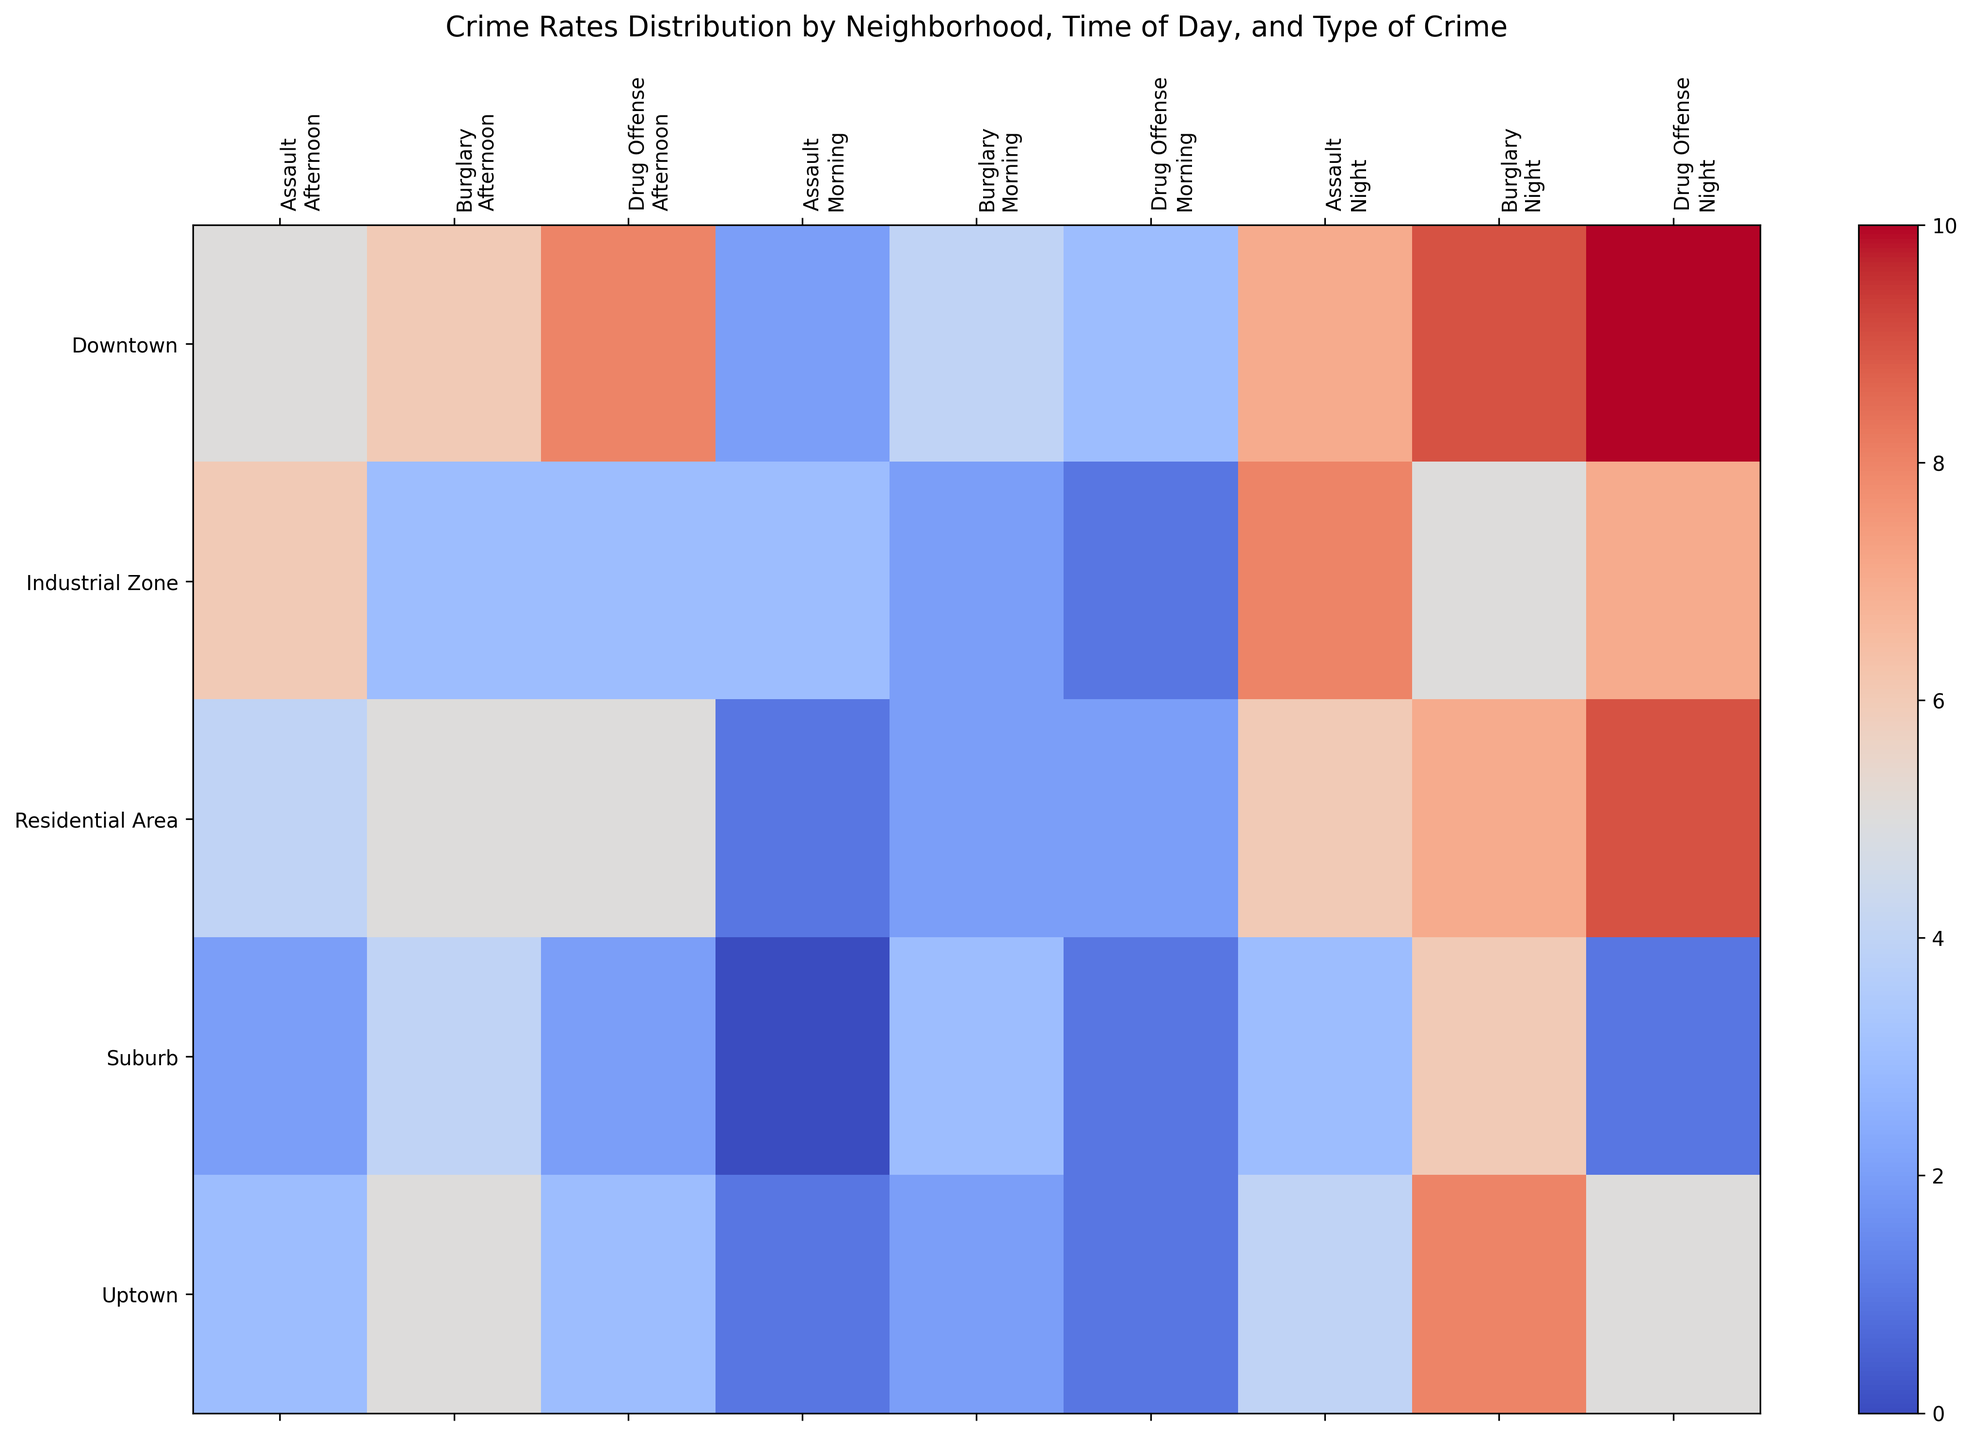Which neighborhood has the highest crime rate for Drug Offenses at night? By looking at the color intensity corresponding to different neighborhoods for Drug Offenses at night, we can see that Downtown has the darkest shade, indicating the highest crime rate.
Answer: Downtown Out of all neighborhoods, which has the smallest variance in Assault rates throughout the day? To find the neighborhood with the smallest variance in Assault rates throughout the day, we look at the variation in color intensity within the Assault column for each neighborhood. The Suburb has the least variation as the shades are more uniform.
Answer: Suburb Is the average Burglary rate in Downtown higher, lower, or equal compared to Uptown? To determine this, calculate the average Burglary rate for both neighborhoods. For Downtown: (4+6+9)/3 = 19/3 = 6.33. For Uptown: (2+5+8)/3 = 15/3 = 5. Therefore, the average Burglary rate in Downtown is higher.
Answer: Higher Which time of the day has the highest average Assault rate across all neighborhoods? Calculate the average Assault rate for Morning, Afternoon, and Night by summing up the values per time and dividing by the number of neighborhoods. The sums are 7 (Morning), 20 (Afternoon), and 28 (Night). Thus, Night has the highest average Assault rate: 28/5 = 5.6.
Answer: Night In which neighborhood and for which type of crime do we see the most intense color gradient from Morning to Night? Observing the heatmap, we identify that Downtown for Drug Offenses shows the most significant color change from a lighter shade in the morning to a very dark shade at night, indicating a steep increase in crime rate.
Answer: Downtown, Drug Offenses Compare the Assault rates between Residential Area and Industrial Zone at night. Which one is higher? By referring to the night's column for Assault, we see that the Industrial Zone has an Assault rate of 8 compared to 6 in the Residential Area, making the Industrial Zone higher.
Answer: Industrial Zone Summarize the change in Burglary rates throughout the day in the Industrial Zone. In the heatmap, note the increasing color intensity for Burglary in the Industrial Zone from Morning (2), Afternoon (3), to Night (5). It indicates a linear increase as the day progresses.
Answer: Increased Which neighborhood has the least severe Drug Offense problem in the morning? Looking at the Drug Offense section for the mornings, the Suburb has the lightest shade, indicating the lowest crime rate of 1.
Answer: Suburb What is the difference in the total number of Drug Offenses between Downtown and Uptown? Sum the Drug Offense rates for all times of day in both neighborhoods. Downtown: 3+8+10 = 21. Uptown: 1+3+5 = 9. The difference is 21 - 9 = 12.
Answer: 12 